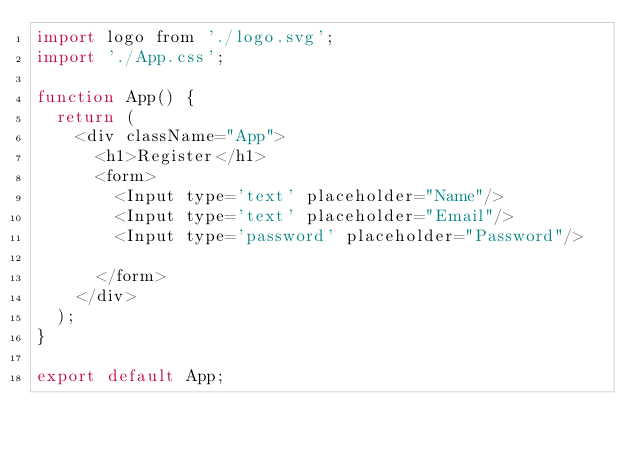<code> <loc_0><loc_0><loc_500><loc_500><_JavaScript_>import logo from './logo.svg';
import './App.css';

function App() {
  return (
    <div className="App">
      <h1>Register</h1>
      <form>
        <Input type='text' placeholder="Name"/>
        <Input type='text' placeholder="Email"/>
        <Input type='password' placeholder="Password"/>

      </form>
    </div>
  );
}

export default App;
</code> 